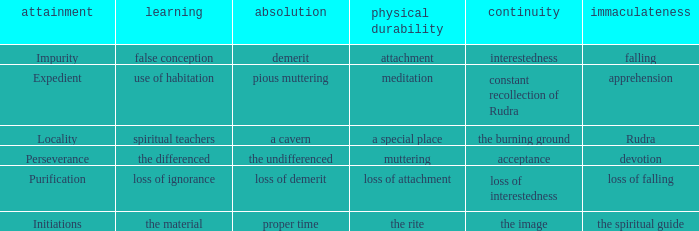Help me parse the entirety of this table. {'header': ['attainment', 'learning', 'absolution', 'physical durability', 'continuity', 'immaculateness'], 'rows': [['Impurity', 'false conception', 'demerit', 'attachment', 'interestedness', 'falling'], ['Expedient', 'use of habitation', 'pious muttering', 'meditation', 'constant recollection of Rudra', 'apprehension'], ['Locality', 'spiritual teachers', 'a cavern', 'a special place', 'the burning ground', 'Rudra'], ['Perseverance', 'the differenced', 'the undifferenced', 'muttering', 'acceptance', 'devotion'], ['Purification', 'loss of ignorance', 'loss of demerit', 'loss of attachment', 'loss of interestedness', 'loss of falling'], ['Initiations', 'the material', 'proper time', 'the rite', 'the image', 'the spiritual guide']]}  what's the permanence of the body where penance is the undifferenced Muttering. 